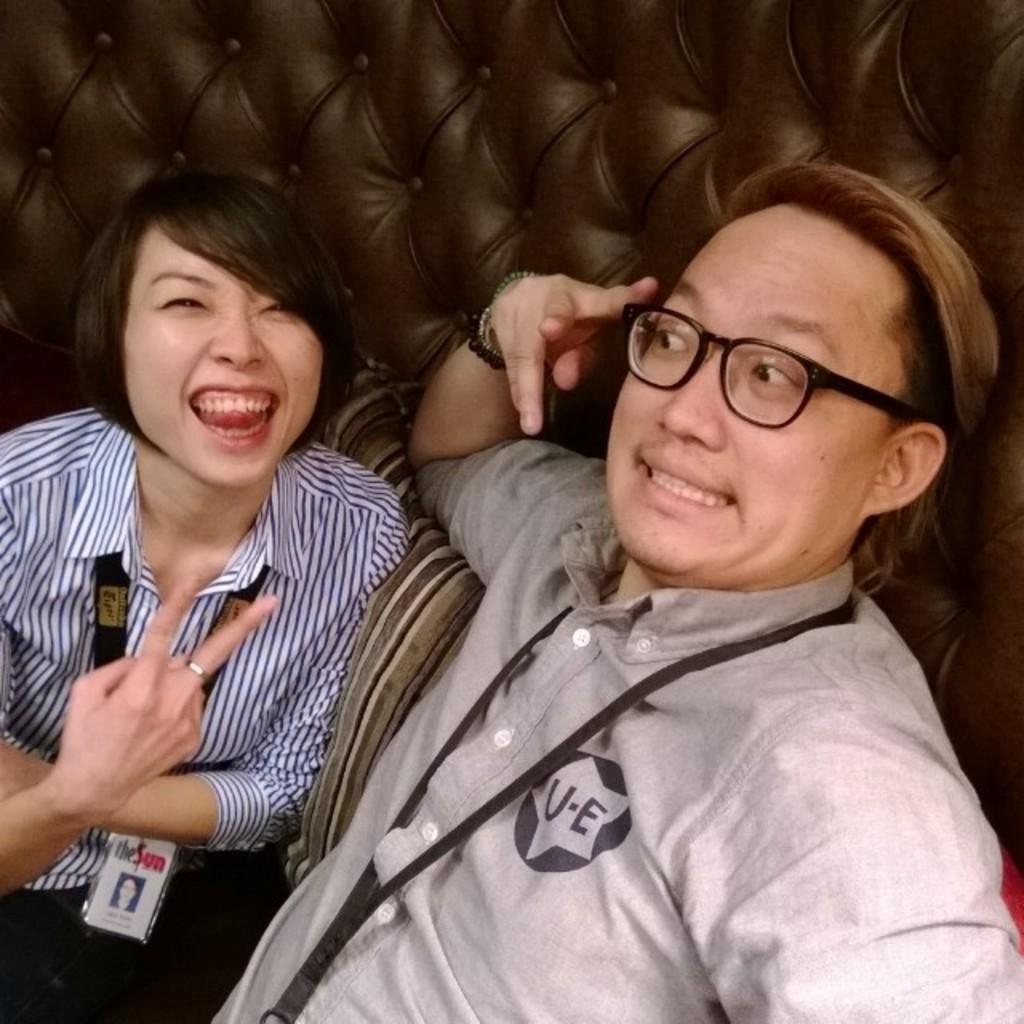What are the people in the image doing? The people in the image are sitting on a couch. What can be seen on the people's clothing in the image? The people in the image are wearing identity cards. What type of accessory is present in the image? There is a pillow in the image. Reasoning: Let's think step by step by step in order to produce the conversation. We start by identifying the main action in the image, which is the people sitting on a couch. Then, we describe the specific detail about the people's clothing, which is the presence of identity cards. Finally, we mention the accessory present in the image, which is the pillow. Each question is designed to elicit a specific detail about the image that is known from the provided facts. Absurd Question/Answer: What type of collar can be seen on the hen in the image? There is no hen present in the image, and therefore no collar can be seen. How many letters are visible on the pillow in the image? There are no letters visible on the pillow in the image. What type of collar can be seen on the hen in the image? There is no hen present in the image, and therefore no collar can be seen. How many letters are visible on the pillow in the image? There are no letters visible on the pillow in the image. 